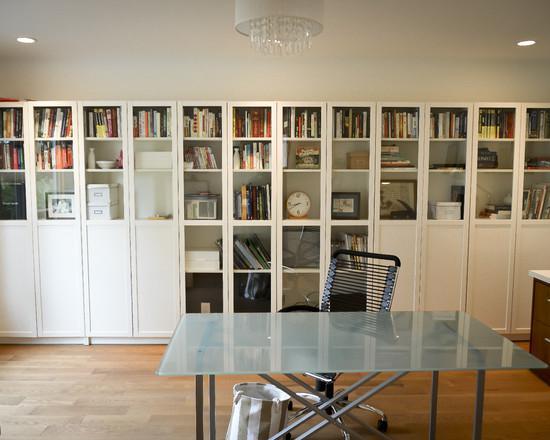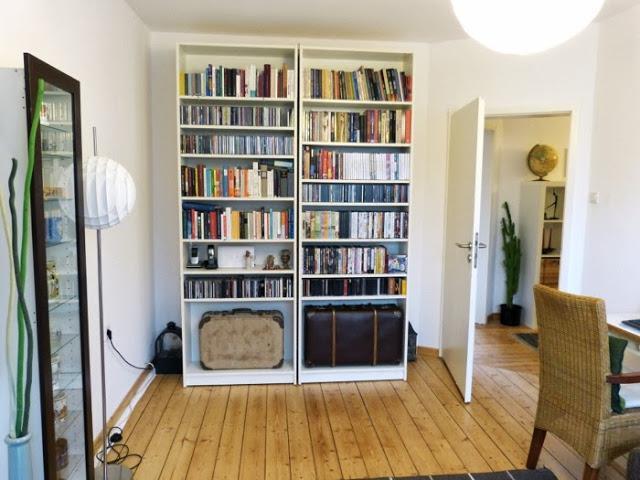The first image is the image on the left, the second image is the image on the right. Analyze the images presented: Is the assertion "In one of the images, a doorway with a view into another room is to the right of a tall white bookcase full of books that are mostly arranged vertically." valid? Answer yes or no. Yes. The first image is the image on the left, the second image is the image on the right. Given the left and right images, does the statement "In at least one image there is a white bookshelf that is part of a kitchen that include silver appliances." hold true? Answer yes or no. No. 